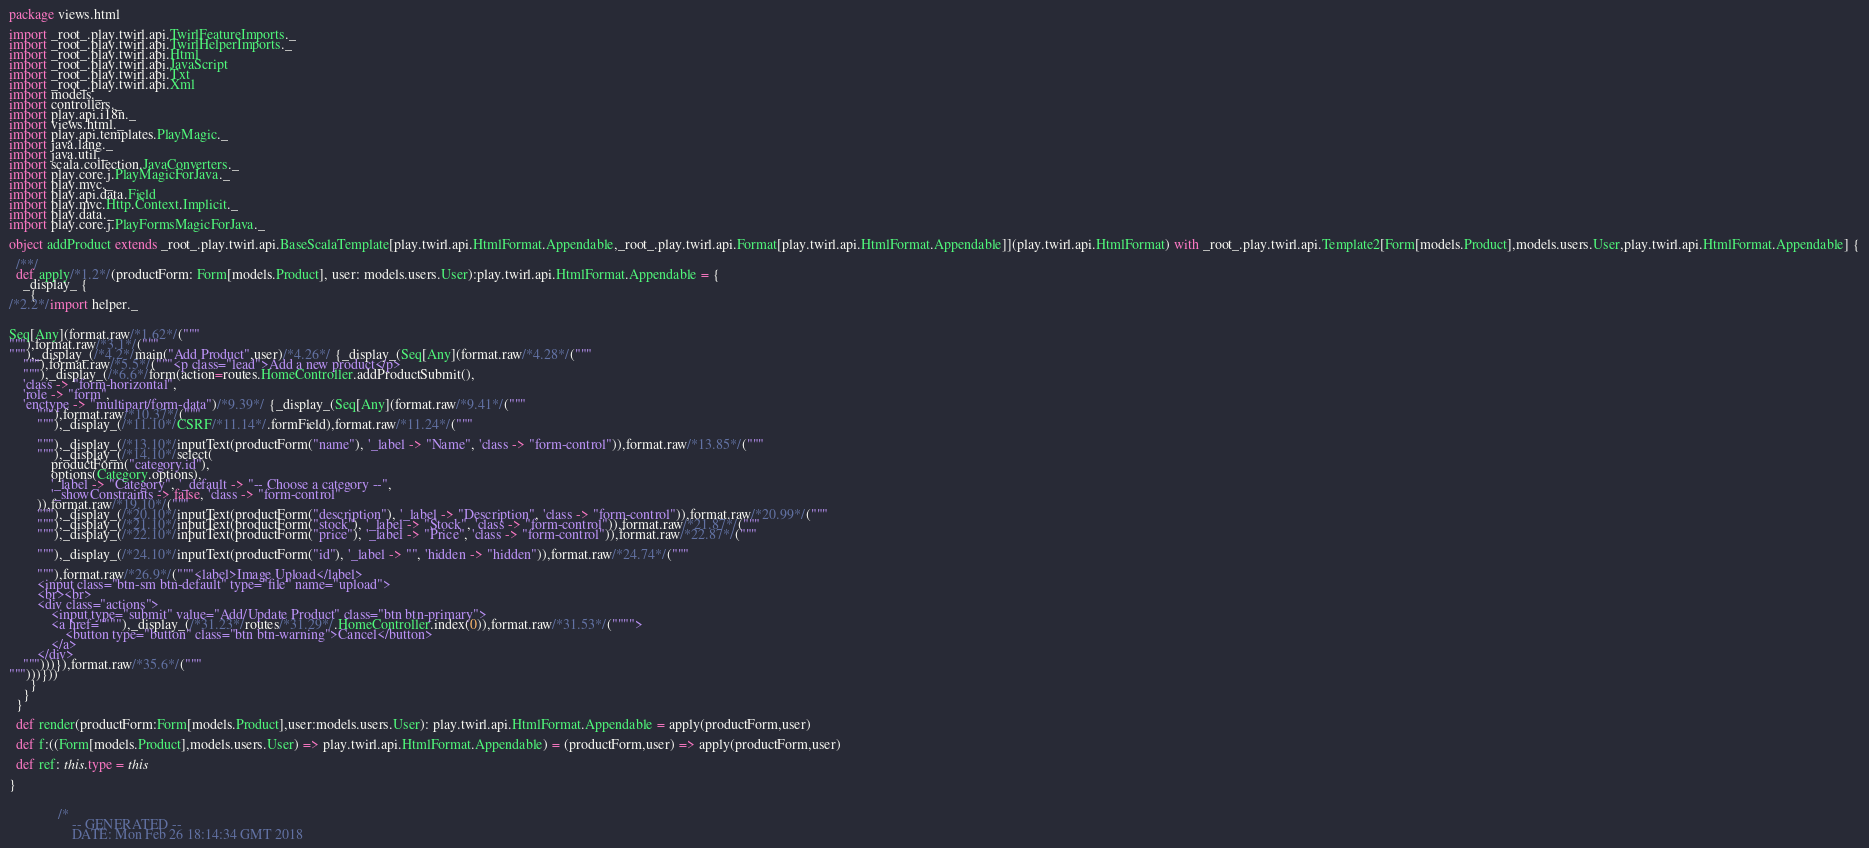Convert code to text. <code><loc_0><loc_0><loc_500><loc_500><_Scala_>
package views.html

import _root_.play.twirl.api.TwirlFeatureImports._
import _root_.play.twirl.api.TwirlHelperImports._
import _root_.play.twirl.api.Html
import _root_.play.twirl.api.JavaScript
import _root_.play.twirl.api.Txt
import _root_.play.twirl.api.Xml
import models._
import controllers._
import play.api.i18n._
import views.html._
import play.api.templates.PlayMagic._
import java.lang._
import java.util._
import scala.collection.JavaConverters._
import play.core.j.PlayMagicForJava._
import play.mvc._
import play.api.data.Field
import play.mvc.Http.Context.Implicit._
import play.data._
import play.core.j.PlayFormsMagicForJava._

object addProduct extends _root_.play.twirl.api.BaseScalaTemplate[play.twirl.api.HtmlFormat.Appendable,_root_.play.twirl.api.Format[play.twirl.api.HtmlFormat.Appendable]](play.twirl.api.HtmlFormat) with _root_.play.twirl.api.Template2[Form[models.Product],models.users.User,play.twirl.api.HtmlFormat.Appendable] {

  /**/
  def apply/*1.2*/(productForm: Form[models.Product], user: models.users.User):play.twirl.api.HtmlFormat.Appendable = {
    _display_ {
      {
/*2.2*/import helper._


Seq[Any](format.raw/*1.62*/("""
"""),format.raw/*3.1*/("""
"""),_display_(/*4.2*/main("Add Product",user)/*4.26*/ {_display_(Seq[Any](format.raw/*4.28*/("""
    """),format.raw/*5.5*/("""<p class="lead">Add a new product</p>
    """),_display_(/*6.6*/form(action=routes.HomeController.addProductSubmit(), 
    'class -> "form-horizontal", 
    'role -> "form",
    'enctype -> "multipart/form-data")/*9.39*/ {_display_(Seq[Any](format.raw/*9.41*/("""
        """),format.raw/*10.37*/("""
        """),_display_(/*11.10*/CSRF/*11.14*/.formField),format.raw/*11.24*/("""

        """),_display_(/*13.10*/inputText(productForm("name"), '_label -> "Name", 'class -> "form-control")),format.raw/*13.85*/("""
        """),_display_(/*14.10*/select(
            productForm("category.id"),
            options(Category.options),
            '_label -> "Category", '_default -> "-- Choose a category --",
            '_showConstraints -> false, 'class -> "form-control"
        )),format.raw/*19.10*/("""
        """),_display_(/*20.10*/inputText(productForm("description"), '_label -> "Description", 'class -> "form-control")),format.raw/*20.99*/("""
        """),_display_(/*21.10*/inputText(productForm("stock"), '_label -> "Stock", 'class -> "form-control")),format.raw/*21.87*/("""
        """),_display_(/*22.10*/inputText(productForm("price"), '_label -> "Price", 'class -> "form-control")),format.raw/*22.87*/("""

        """),_display_(/*24.10*/inputText(productForm("id"), '_label -> "", 'hidden -> "hidden")),format.raw/*24.74*/("""
        
        """),format.raw/*26.9*/("""<label>Image Upload</label>
        <input class="btn-sm btn-default" type="file" name="upload">
        <br><br>
        <div class="actions">
            <input type="submit" value="Add/Update Product" class="btn btn-primary">
            <a href=""""),_display_(/*31.23*/routes/*31.29*/.HomeController.index(0)),format.raw/*31.53*/("""">
                <button type="button" class="btn btn-warning">Cancel</button>
            </a>
        </div>
    """)))}),format.raw/*35.6*/("""
""")))}))
      }
    }
  }

  def render(productForm:Form[models.Product],user:models.users.User): play.twirl.api.HtmlFormat.Appendable = apply(productForm,user)

  def f:((Form[models.Product],models.users.User) => play.twirl.api.HtmlFormat.Appendable) = (productForm,user) => apply(productForm,user)

  def ref: this.type = this

}


              /*
                  -- GENERATED --
                  DATE: Mon Feb 26 18:14:34 GMT 2018</code> 